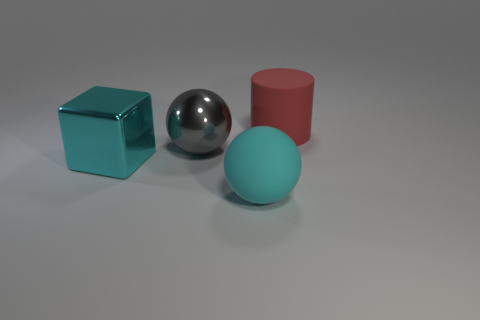Subtract 1 cylinders. How many cylinders are left? 0 Subtract all gray balls. How many balls are left? 1 Add 2 big balls. How many objects exist? 6 Subtract all red spheres. Subtract all blue cubes. How many spheres are left? 2 Subtract all yellow cylinders. How many red blocks are left? 0 Subtract all large cyan spheres. Subtract all cyan rubber objects. How many objects are left? 2 Add 1 big blocks. How many big blocks are left? 2 Add 2 cyan blocks. How many cyan blocks exist? 3 Subtract 0 brown cylinders. How many objects are left? 4 